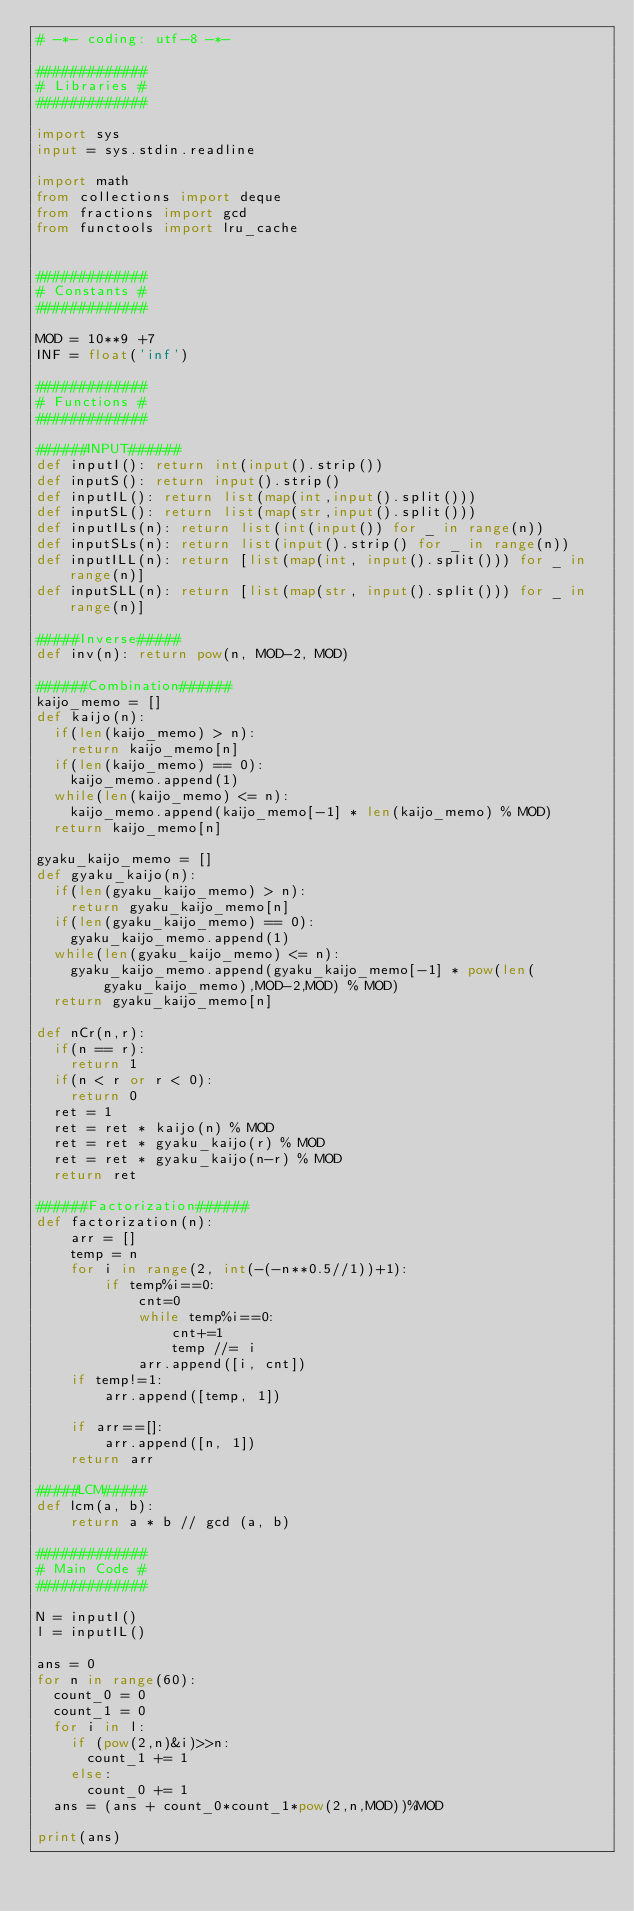<code> <loc_0><loc_0><loc_500><loc_500><_Python_># -*- coding: utf-8 -*-

#############
# Libraries #
#############

import sys
input = sys.stdin.readline

import math
from collections import deque
from fractions import gcd
from functools import lru_cache


#############
# Constants #
#############

MOD = 10**9 +7
INF = float('inf')

#############
# Functions #
#############

######INPUT######
def inputI(): return int(input().strip())
def inputS(): return input().strip()
def inputIL(): return list(map(int,input().split()))
def inputSL(): return list(map(str,input().split()))
def inputILs(n): return list(int(input()) for _ in range(n))
def inputSLs(n): return list(input().strip() for _ in range(n))
def inputILL(n): return [list(map(int, input().split())) for _ in range(n)]
def inputSLL(n): return [list(map(str, input().split())) for _ in range(n)]

#####Inverse#####
def inv(n): return pow(n, MOD-2, MOD)

######Combination######
kaijo_memo = []
def kaijo(n):
  if(len(kaijo_memo) > n):
    return kaijo_memo[n]
  if(len(kaijo_memo) == 0):
    kaijo_memo.append(1)
  while(len(kaijo_memo) <= n):
    kaijo_memo.append(kaijo_memo[-1] * len(kaijo_memo) % MOD)
  return kaijo_memo[n]

gyaku_kaijo_memo = []
def gyaku_kaijo(n):
  if(len(gyaku_kaijo_memo) > n):
    return gyaku_kaijo_memo[n]
  if(len(gyaku_kaijo_memo) == 0):
    gyaku_kaijo_memo.append(1)
  while(len(gyaku_kaijo_memo) <= n):
    gyaku_kaijo_memo.append(gyaku_kaijo_memo[-1] * pow(len(gyaku_kaijo_memo),MOD-2,MOD) % MOD)
  return gyaku_kaijo_memo[n]

def nCr(n,r):
  if(n == r):
    return 1
  if(n < r or r < 0):
    return 0
  ret = 1
  ret = ret * kaijo(n) % MOD
  ret = ret * gyaku_kaijo(r) % MOD
  ret = ret * gyaku_kaijo(n-r) % MOD
  return ret

######Factorization######
def factorization(n):
    arr = []
    temp = n
    for i in range(2, int(-(-n**0.5//1))+1):
        if temp%i==0:
            cnt=0
            while temp%i==0:
                cnt+=1
                temp //= i
            arr.append([i, cnt])
    if temp!=1:
        arr.append([temp, 1])

    if arr==[]:
        arr.append([n, 1])
    return arr

#####LCM#####
def lcm(a, b):
    return a * b // gcd (a, b)

#############
# Main Code #
#############

N = inputI()
l = inputIL()

ans = 0
for n in range(60):
  count_0 = 0
  count_1 = 0
  for i in l:
    if (pow(2,n)&i)>>n:
      count_1 += 1
    else:
      count_0 += 1
  ans = (ans + count_0*count_1*pow(2,n,MOD))%MOD
  
print(ans)</code> 